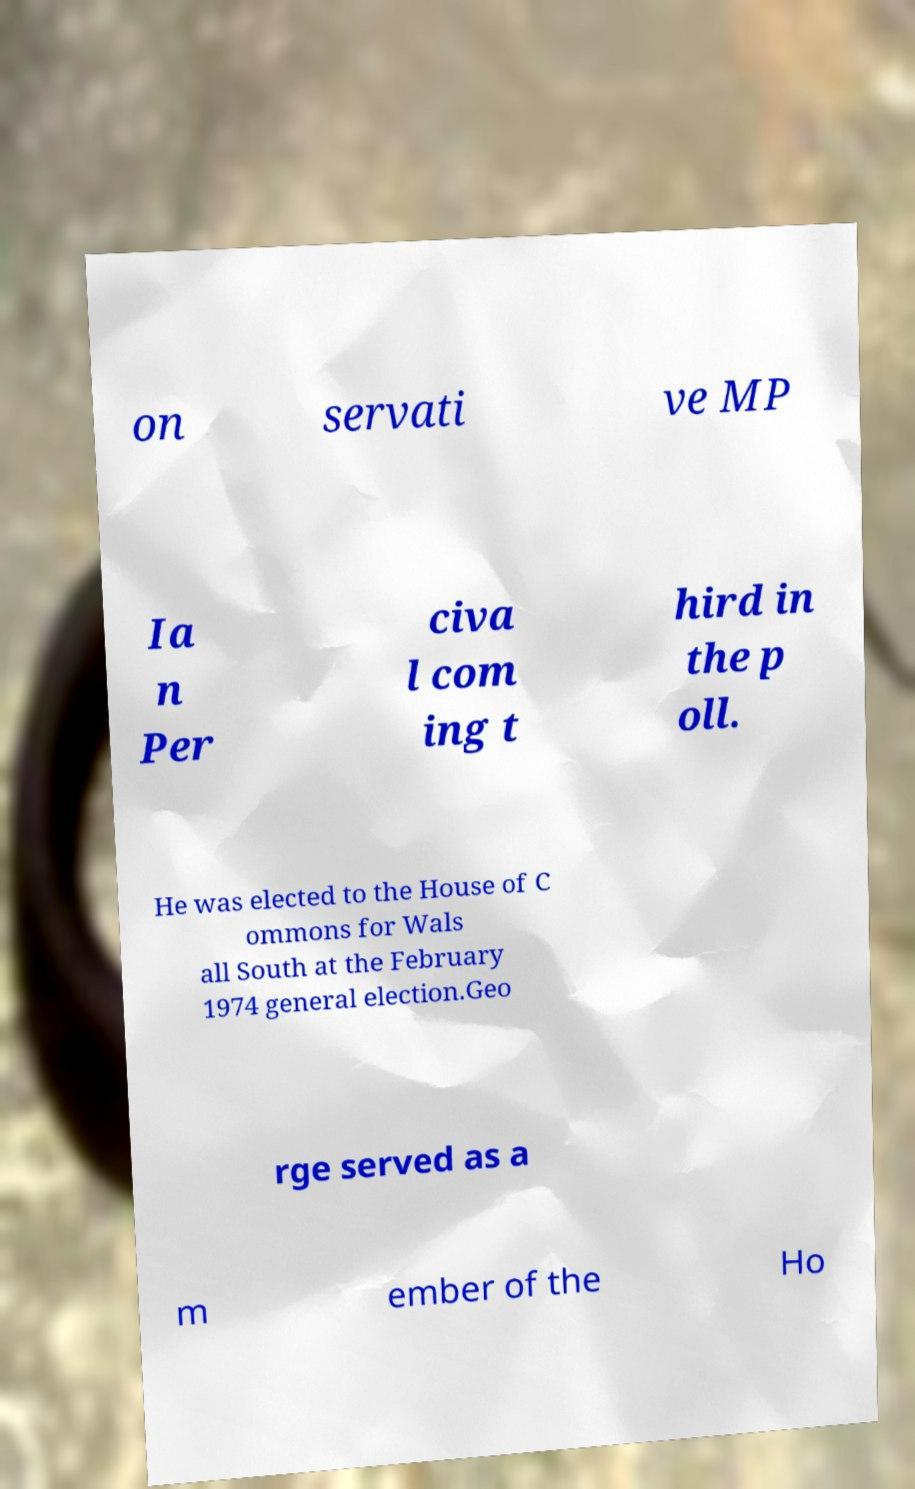Could you extract and type out the text from this image? on servati ve MP Ia n Per civa l com ing t hird in the p oll. He was elected to the House of C ommons for Wals all South at the February 1974 general election.Geo rge served as a m ember of the Ho 